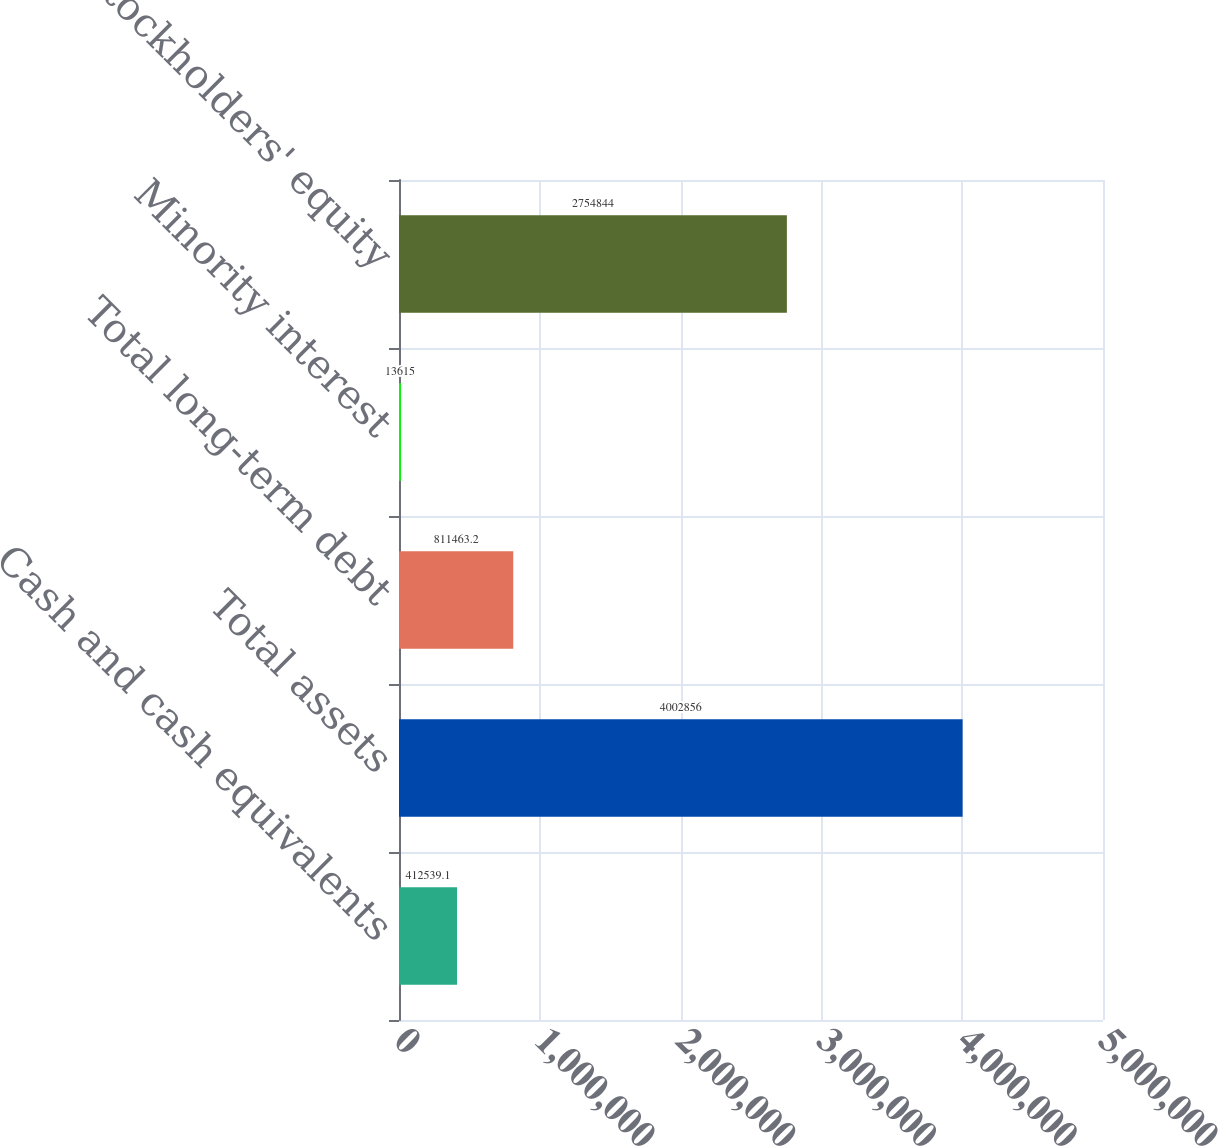Convert chart to OTSL. <chart><loc_0><loc_0><loc_500><loc_500><bar_chart><fcel>Cash and cash equivalents<fcel>Total assets<fcel>Total long-term debt<fcel>Minority interest<fcel>Total stockholders' equity<nl><fcel>412539<fcel>4.00286e+06<fcel>811463<fcel>13615<fcel>2.75484e+06<nl></chart> 